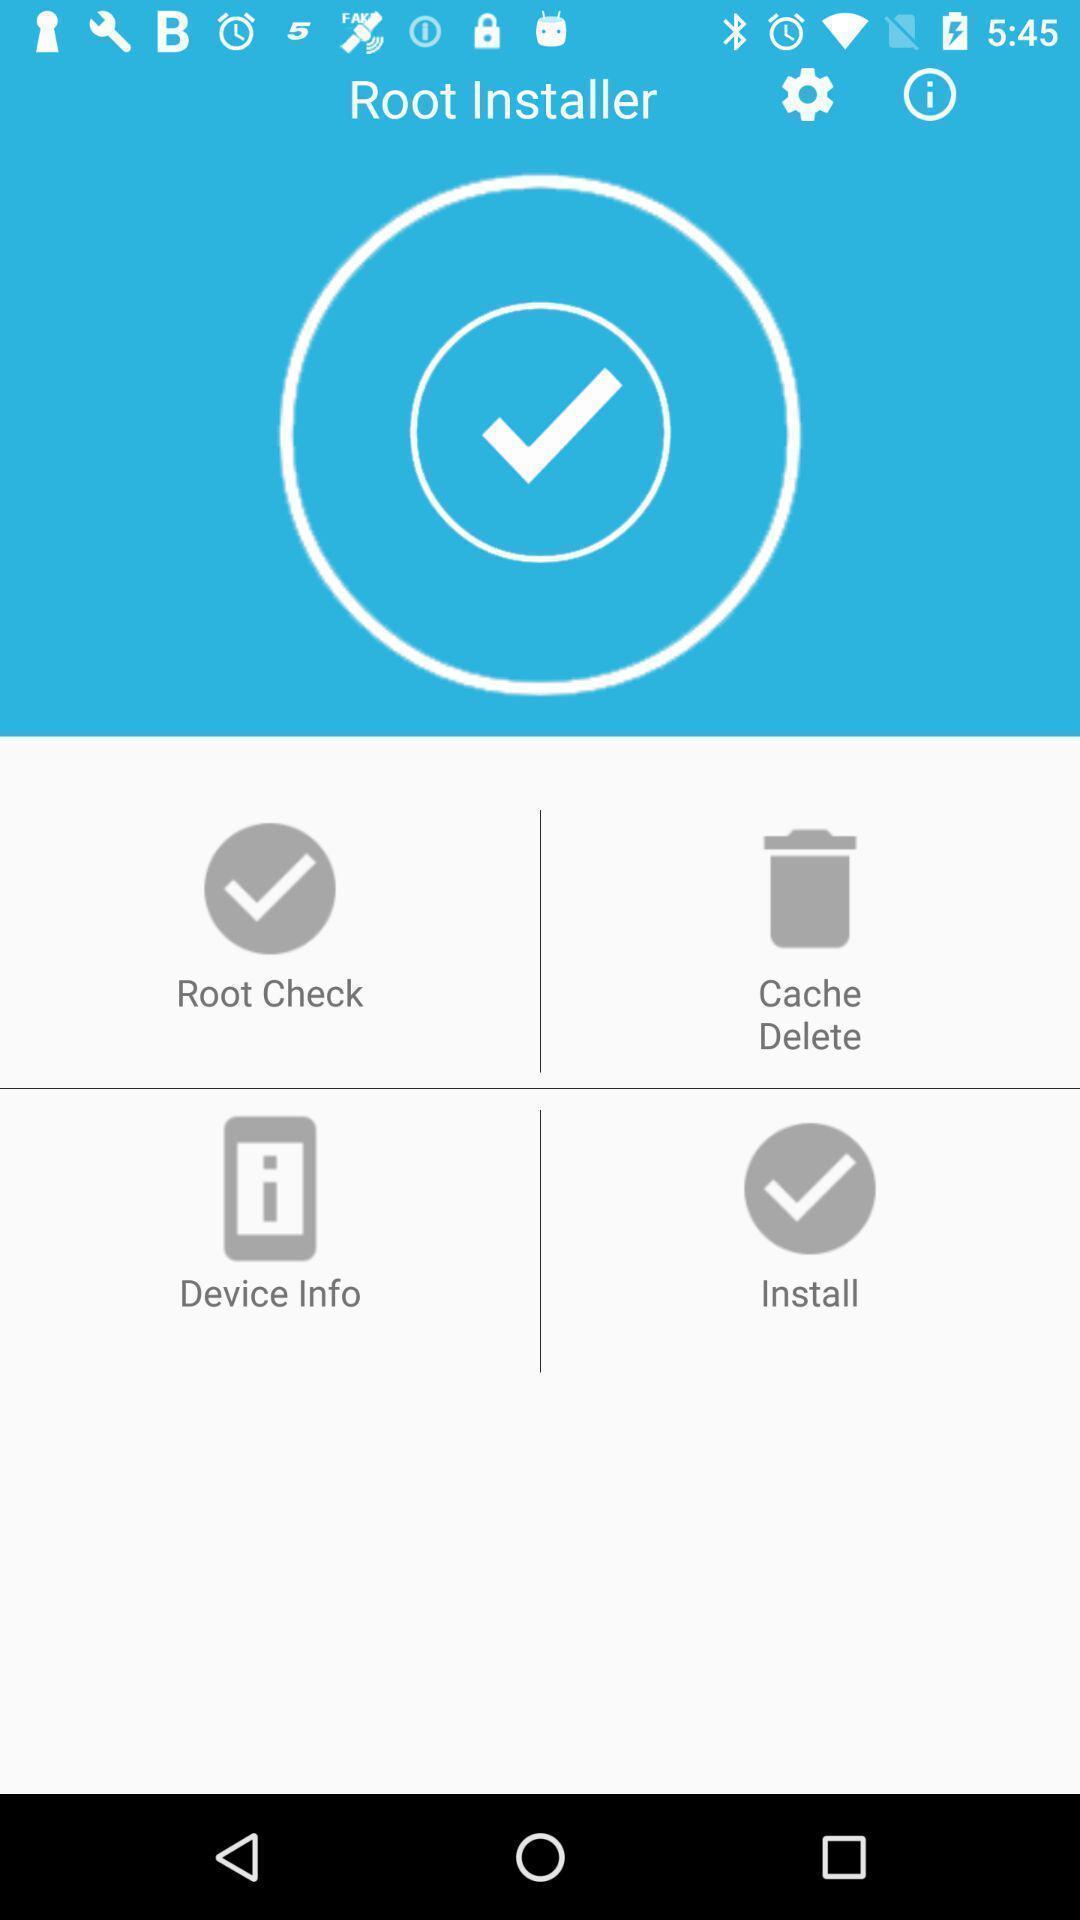Please provide a description for this image. Screen displaying multiple setting options. 